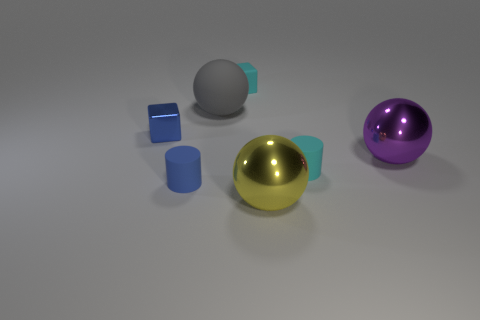Are there more cyan rubber cylinders that are on the left side of the large yellow sphere than large purple objects?
Provide a short and direct response. No. Is there anything else that is the same shape as the large gray object?
Your answer should be compact. Yes. The other rubber thing that is the same shape as the small blue rubber thing is what color?
Provide a succinct answer. Cyan. There is a small blue rubber object that is to the left of the gray ball; what is its shape?
Ensure brevity in your answer.  Cylinder. Are there any yellow spheres behind the big purple shiny sphere?
Keep it short and to the point. No. Is there anything else that has the same size as the cyan cylinder?
Provide a succinct answer. Yes. What color is the other big thing that is the same material as the large purple object?
Give a very brief answer. Yellow. There is a rubber object that is on the right side of the yellow metal object; is it the same color as the rubber cylinder on the left side of the yellow sphere?
Give a very brief answer. No. What number of cylinders are small blue matte objects or tiny objects?
Provide a succinct answer. 2. Is the number of tiny metal cubes in front of the big purple thing the same as the number of tiny metallic objects?
Your response must be concise. No. 